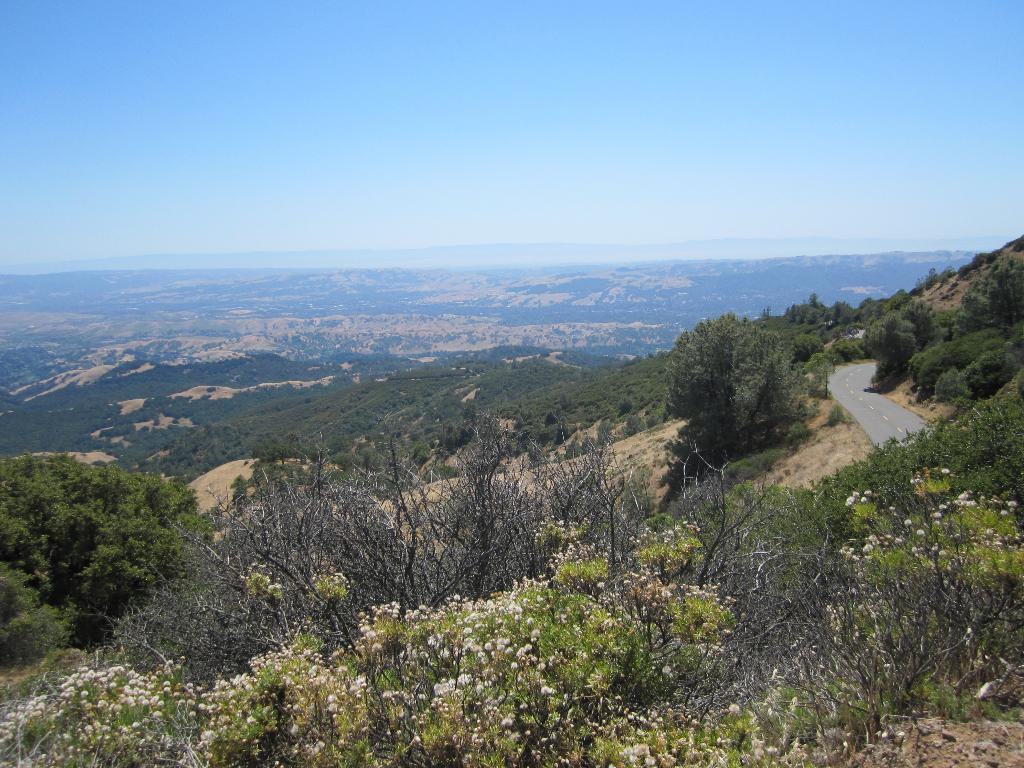What type of pathway is visible in the image? There is a road in the image. What natural elements can be seen alongside the road? There are trees in the image. What type of landscape feature is visible in the distance? There are mountains in the image. What is visible in the background of the image? The sky is visible in the background of the image. How many twigs are scattered on the road in the image? There is no mention of twigs in the image; they are not present. 